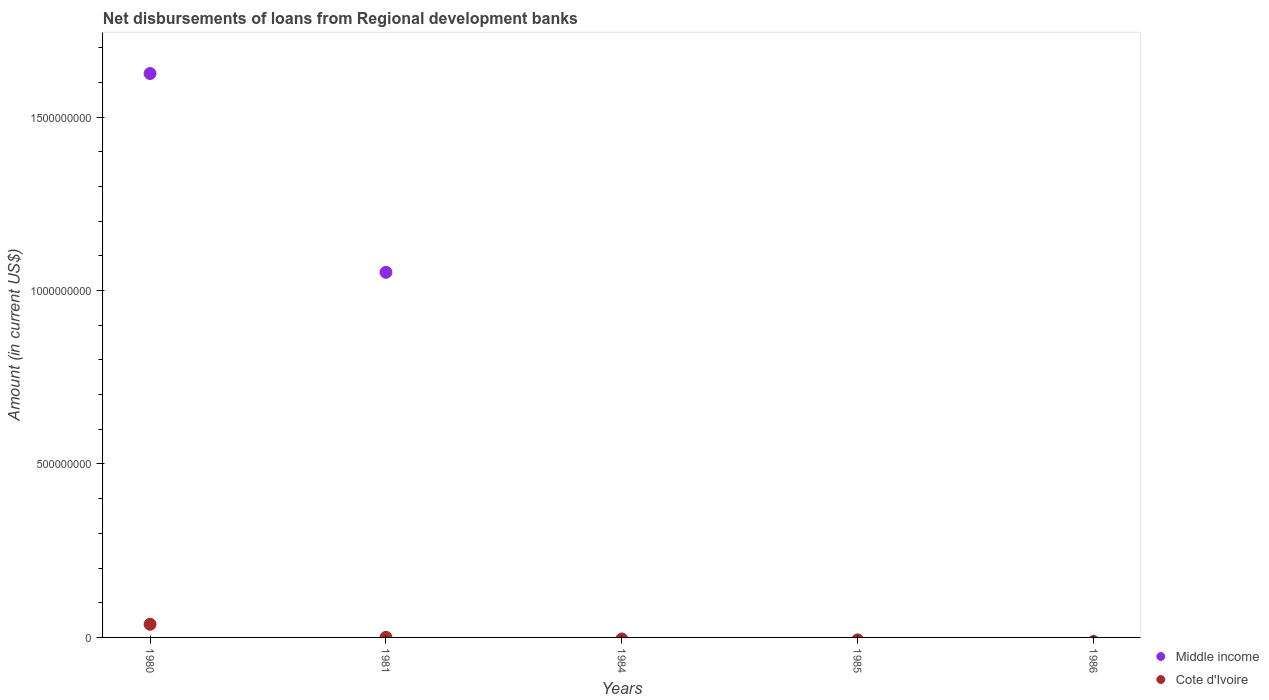What is the amount of disbursements of loans from regional development banks in Cote d'Ivoire in 1981?
Offer a terse response. 2.31e+05. Across all years, what is the maximum amount of disbursements of loans from regional development banks in Middle income?
Your answer should be compact. 1.63e+09. Across all years, what is the minimum amount of disbursements of loans from regional development banks in Cote d'Ivoire?
Provide a short and direct response. 0. In which year was the amount of disbursements of loans from regional development banks in Middle income maximum?
Provide a short and direct response. 1980. What is the total amount of disbursements of loans from regional development banks in Middle income in the graph?
Your response must be concise. 2.68e+09. What is the difference between the amount of disbursements of loans from regional development banks in Middle income in 1986 and the amount of disbursements of loans from regional development banks in Cote d'Ivoire in 1980?
Your response must be concise. -3.78e+07. What is the average amount of disbursements of loans from regional development banks in Cote d'Ivoire per year?
Offer a very short reply. 7.61e+06. In the year 1981, what is the difference between the amount of disbursements of loans from regional development banks in Cote d'Ivoire and amount of disbursements of loans from regional development banks in Middle income?
Offer a terse response. -1.05e+09. What is the ratio of the amount of disbursements of loans from regional development banks in Middle income in 1980 to that in 1981?
Offer a very short reply. 1.54. What is the difference between the highest and the lowest amount of disbursements of loans from regional development banks in Middle income?
Give a very brief answer. 1.63e+09. Does the amount of disbursements of loans from regional development banks in Middle income monotonically increase over the years?
Provide a short and direct response. No. Is the amount of disbursements of loans from regional development banks in Middle income strictly less than the amount of disbursements of loans from regional development banks in Cote d'Ivoire over the years?
Offer a very short reply. No. How many dotlines are there?
Make the answer very short. 2. How many years are there in the graph?
Keep it short and to the point. 5. What is the difference between two consecutive major ticks on the Y-axis?
Keep it short and to the point. 5.00e+08. Does the graph contain any zero values?
Provide a short and direct response. Yes. Does the graph contain grids?
Provide a short and direct response. No. What is the title of the graph?
Offer a very short reply. Net disbursements of loans from Regional development banks. Does "Canada" appear as one of the legend labels in the graph?
Give a very brief answer. No. What is the label or title of the X-axis?
Your response must be concise. Years. What is the Amount (in current US$) in Middle income in 1980?
Your answer should be compact. 1.63e+09. What is the Amount (in current US$) of Cote d'Ivoire in 1980?
Offer a terse response. 3.78e+07. What is the Amount (in current US$) of Middle income in 1981?
Provide a short and direct response. 1.05e+09. What is the Amount (in current US$) in Cote d'Ivoire in 1981?
Make the answer very short. 2.31e+05. What is the Amount (in current US$) of Middle income in 1984?
Make the answer very short. 0. What is the Amount (in current US$) of Middle income in 1985?
Ensure brevity in your answer.  0. What is the Amount (in current US$) of Cote d'Ivoire in 1985?
Give a very brief answer. 0. What is the Amount (in current US$) in Middle income in 1986?
Offer a terse response. 0. Across all years, what is the maximum Amount (in current US$) of Middle income?
Offer a very short reply. 1.63e+09. Across all years, what is the maximum Amount (in current US$) in Cote d'Ivoire?
Keep it short and to the point. 3.78e+07. What is the total Amount (in current US$) of Middle income in the graph?
Provide a short and direct response. 2.68e+09. What is the total Amount (in current US$) in Cote d'Ivoire in the graph?
Make the answer very short. 3.81e+07. What is the difference between the Amount (in current US$) of Middle income in 1980 and that in 1981?
Provide a succinct answer. 5.73e+08. What is the difference between the Amount (in current US$) of Cote d'Ivoire in 1980 and that in 1981?
Make the answer very short. 3.76e+07. What is the difference between the Amount (in current US$) of Middle income in 1980 and the Amount (in current US$) of Cote d'Ivoire in 1981?
Provide a succinct answer. 1.63e+09. What is the average Amount (in current US$) of Middle income per year?
Provide a short and direct response. 5.36e+08. What is the average Amount (in current US$) of Cote d'Ivoire per year?
Your response must be concise. 7.61e+06. In the year 1980, what is the difference between the Amount (in current US$) of Middle income and Amount (in current US$) of Cote d'Ivoire?
Your response must be concise. 1.59e+09. In the year 1981, what is the difference between the Amount (in current US$) in Middle income and Amount (in current US$) in Cote d'Ivoire?
Keep it short and to the point. 1.05e+09. What is the ratio of the Amount (in current US$) of Middle income in 1980 to that in 1981?
Provide a short and direct response. 1.54. What is the ratio of the Amount (in current US$) in Cote d'Ivoire in 1980 to that in 1981?
Offer a terse response. 163.78. What is the difference between the highest and the lowest Amount (in current US$) in Middle income?
Make the answer very short. 1.63e+09. What is the difference between the highest and the lowest Amount (in current US$) of Cote d'Ivoire?
Offer a terse response. 3.78e+07. 